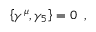Convert formula to latex. <formula><loc_0><loc_0><loc_500><loc_500>\left \{ \gamma ^ { \mu } , \gamma _ { 5 } \right \} = 0 \, ,</formula> 